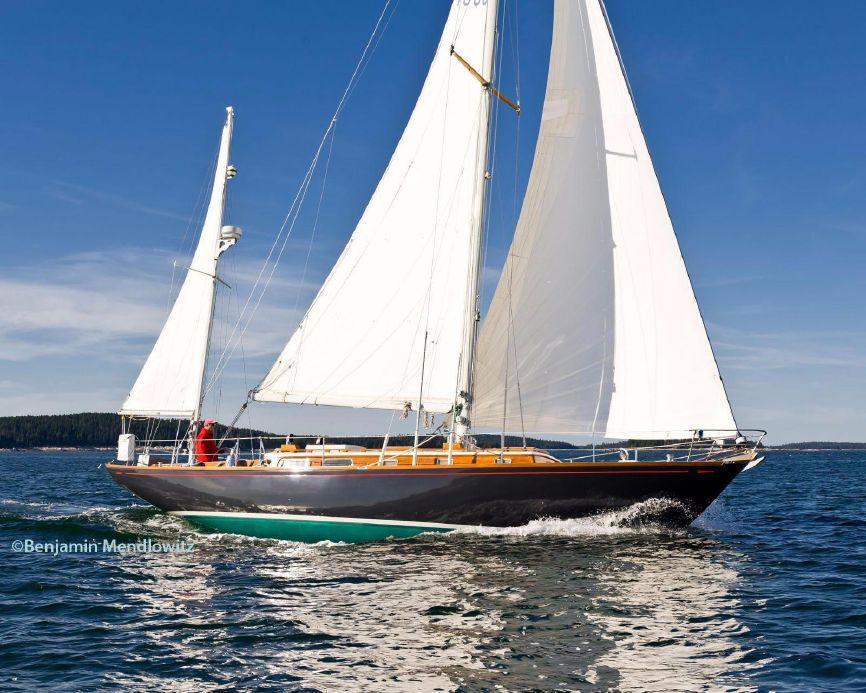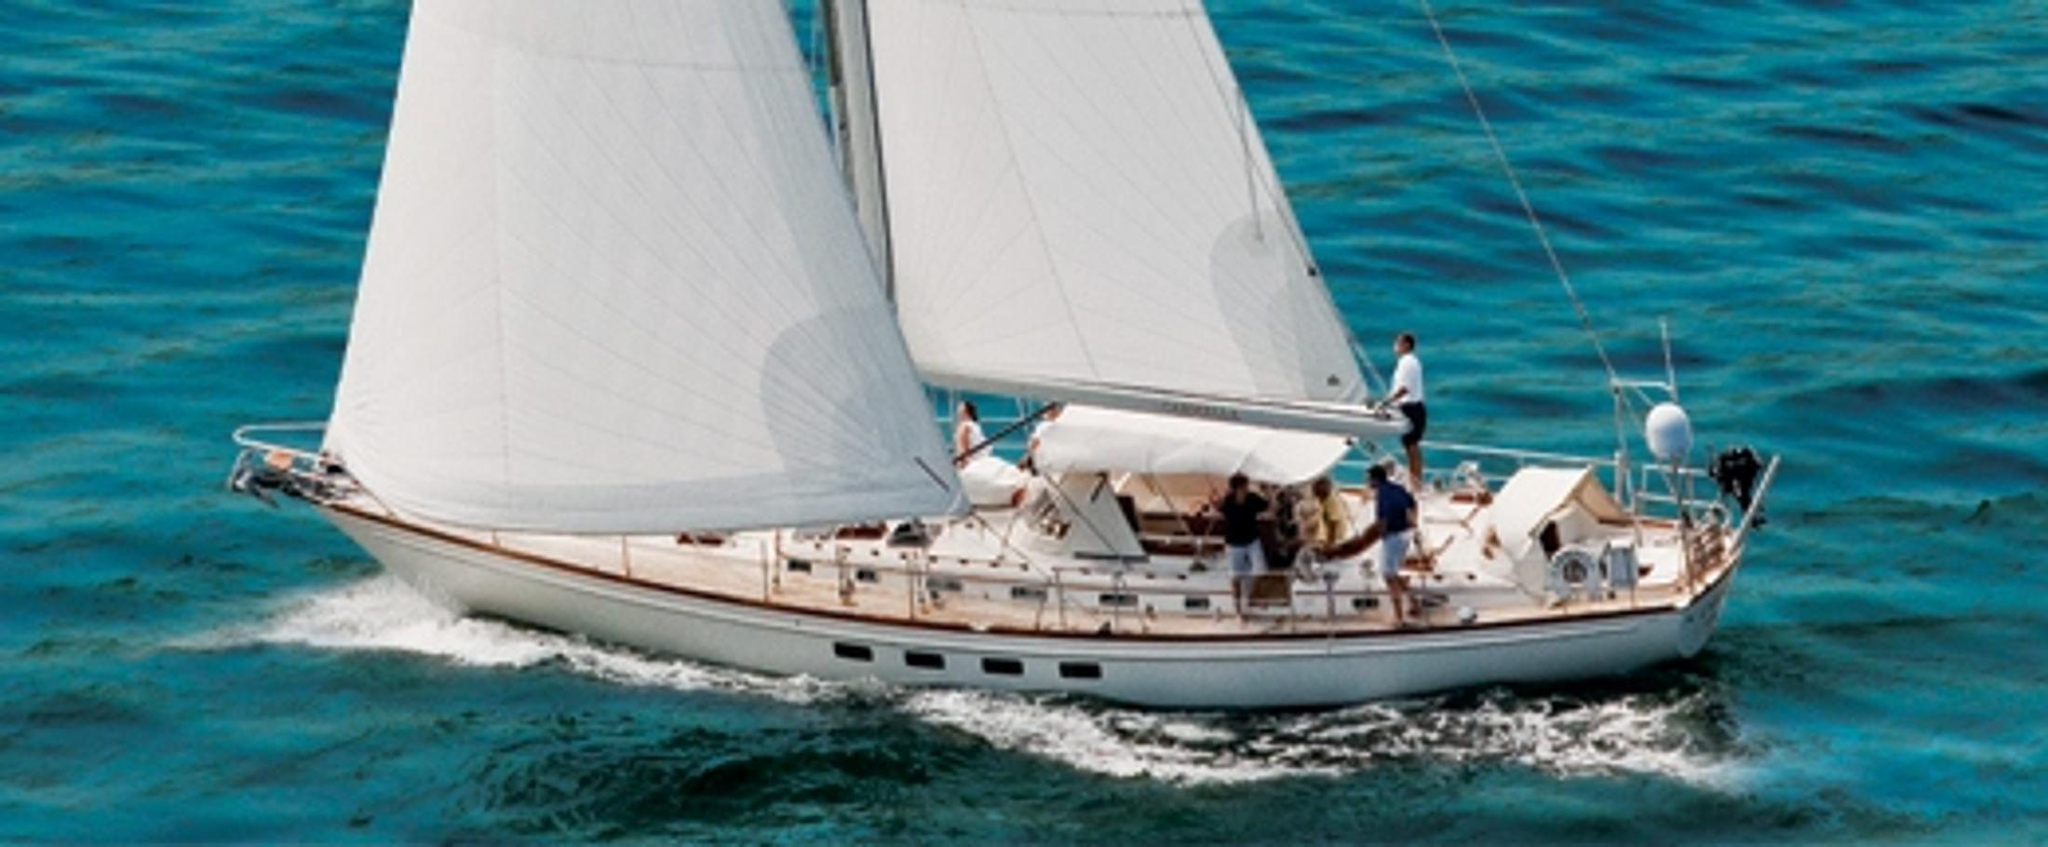The first image is the image on the left, the second image is the image on the right. Evaluate the accuracy of this statement regarding the images: "One of the images contains a single sailboat with three sails". Is it true? Answer yes or no. Yes. 